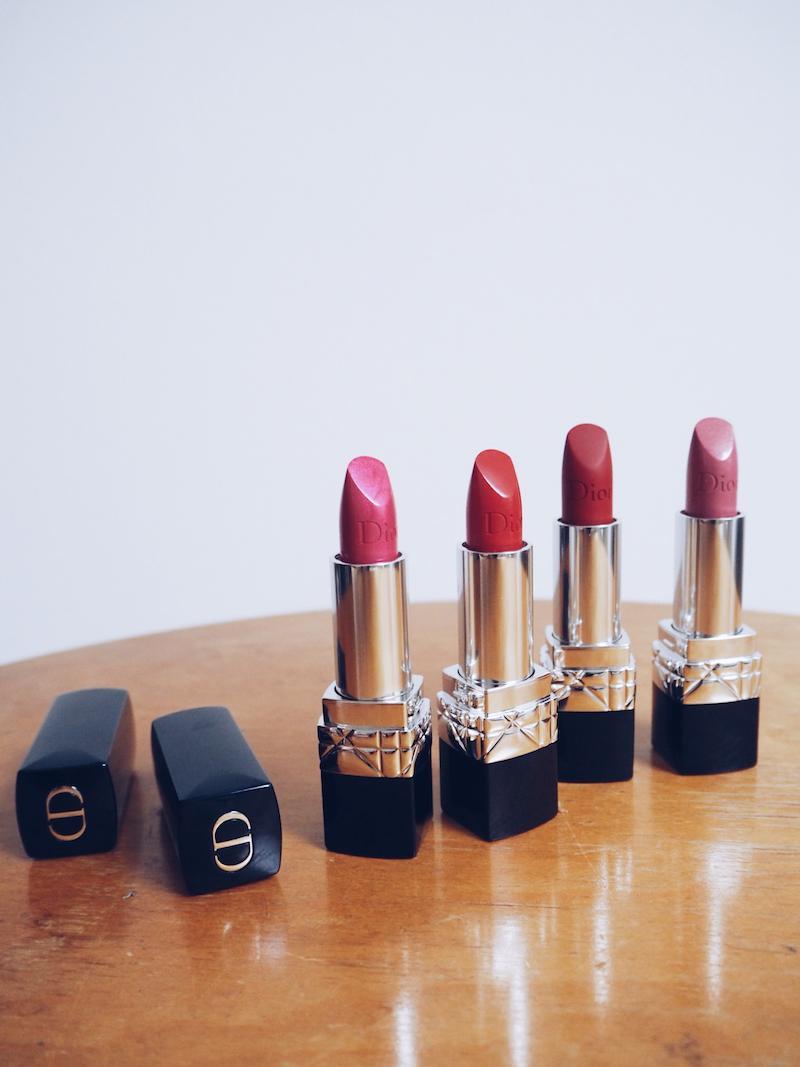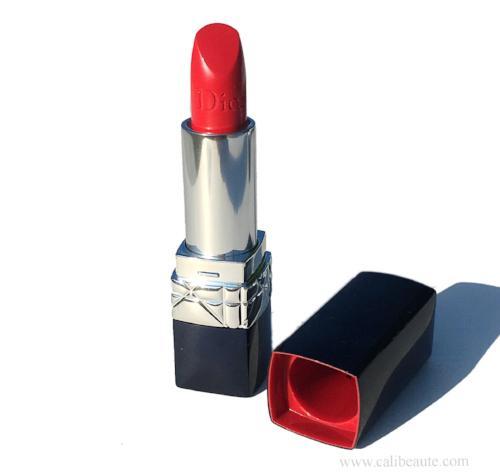The first image is the image on the left, the second image is the image on the right. Given the left and right images, does the statement "A red lipstick in a silver tube is displayed level to and alongside of its upright black cap." hold true? Answer yes or no. No. The first image is the image on the left, the second image is the image on the right. Considering the images on both sides, is "A red lipstick in one image is in a silver holder with black base, with a matching black cap with silver band sitting upright and level beside it." valid? Answer yes or no. No. 